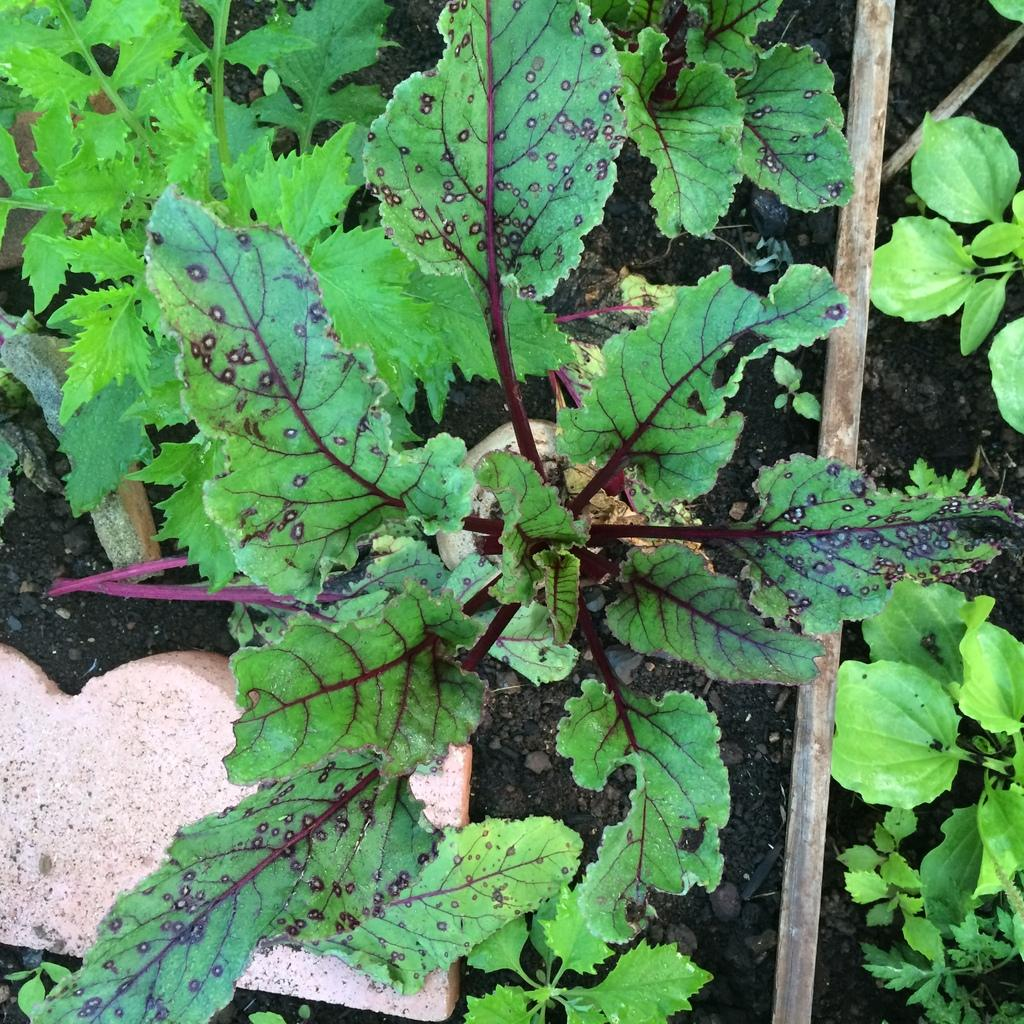What is present on both sides of the image? There are plants on both the right and left sides of the image. What object can be seen on the left side of the image? There is an object that looks like a bread on the left side of the image. What type of reading material is visible on the right side of the image? There is no reading material present on the right side of the image; it features plants. What type of metal object can be seen on the left side of the image? There is no metal object present on the left side of the image; it features an object that looks like a bread. 